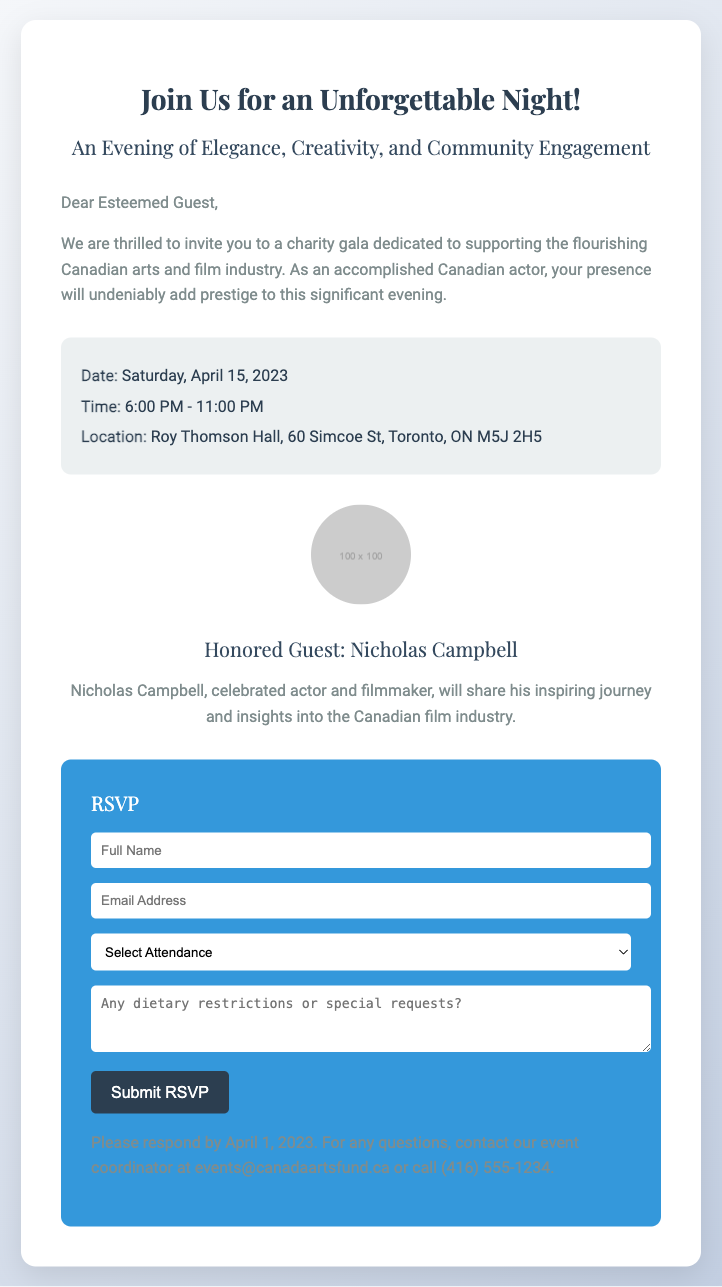what is the date of the gala? The date of the gala is explicitly stated in the event details section of the document.
Answer: Saturday, April 15, 2023 what is the time duration of the event? The time of the gala is provided and shows the starting and ending times, thus determining the duration.
Answer: 6:00 PM - 11:00 PM where is the gala taking place? The location is mentioned in the event details, specifying where the event will occur.
Answer: Roy Thomson Hall, 60 Simcoe St, Toronto, ON M5J 2H5 who is the honored guest? The document clearly specifies the honored guest along with their contribution to the event, including their profession.
Answer: Nicholas Campbell what is the RSVP deadline? The RSVP deadline is provided at the end of the RSVP form, indicating when responses must be submitted.
Answer: April 1, 2023 what is the purpose of this gala? The purpose of the gala is highlighted in the introductory paragraph describing its aim and significance.
Answer: Supporting the flourishing Canadian arts and film industry what should you include in the RSVP form? The RSVP form highlights the necessary fields that guests are required to fill out when responding.
Answer: Full Name, Email Address, Attendance Selection, Dietary Restrictions how can attendees contact for questions regarding the event? Contact information for inquiries is provided, which specifies the means of communication.
Answer: events@canadaartsfund.ca or (416) 555-1234 